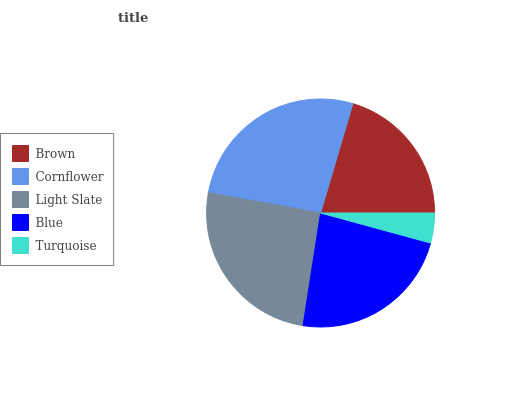Is Turquoise the minimum?
Answer yes or no. Yes. Is Cornflower the maximum?
Answer yes or no. Yes. Is Light Slate the minimum?
Answer yes or no. No. Is Light Slate the maximum?
Answer yes or no. No. Is Cornflower greater than Light Slate?
Answer yes or no. Yes. Is Light Slate less than Cornflower?
Answer yes or no. Yes. Is Light Slate greater than Cornflower?
Answer yes or no. No. Is Cornflower less than Light Slate?
Answer yes or no. No. Is Blue the high median?
Answer yes or no. Yes. Is Blue the low median?
Answer yes or no. Yes. Is Turquoise the high median?
Answer yes or no. No. Is Turquoise the low median?
Answer yes or no. No. 